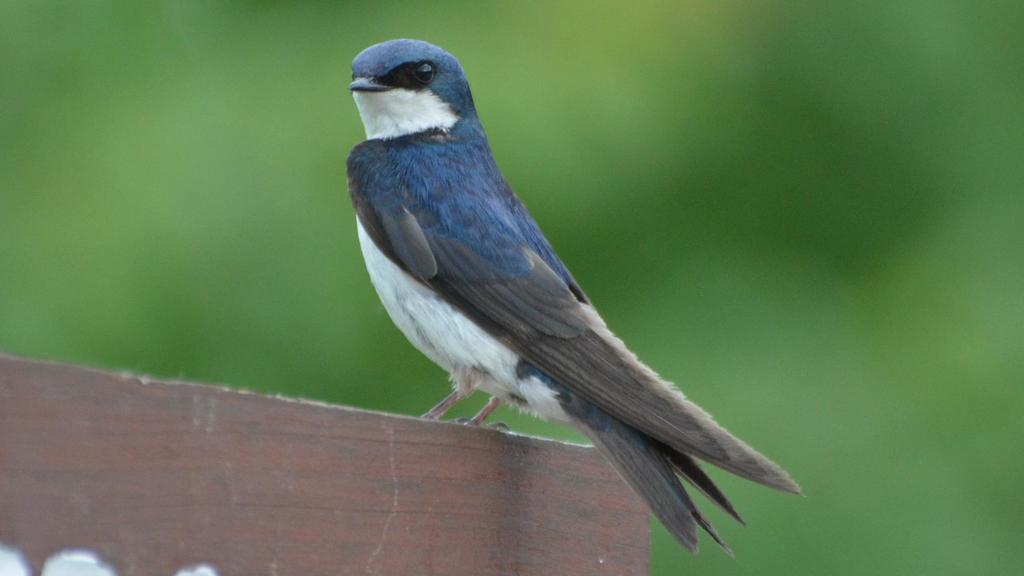What animal can be seen in the image? There is a bird on a wooden surface in the image. What is the bird standing on? The bird is standing on a wooden surface. What color is predominant in the background of the image? The background color is green. What type of border is visible around the bird in the image? There is no border visible around the bird in the image. Is there a beggar present in the image? There is no beggar present in the image. 